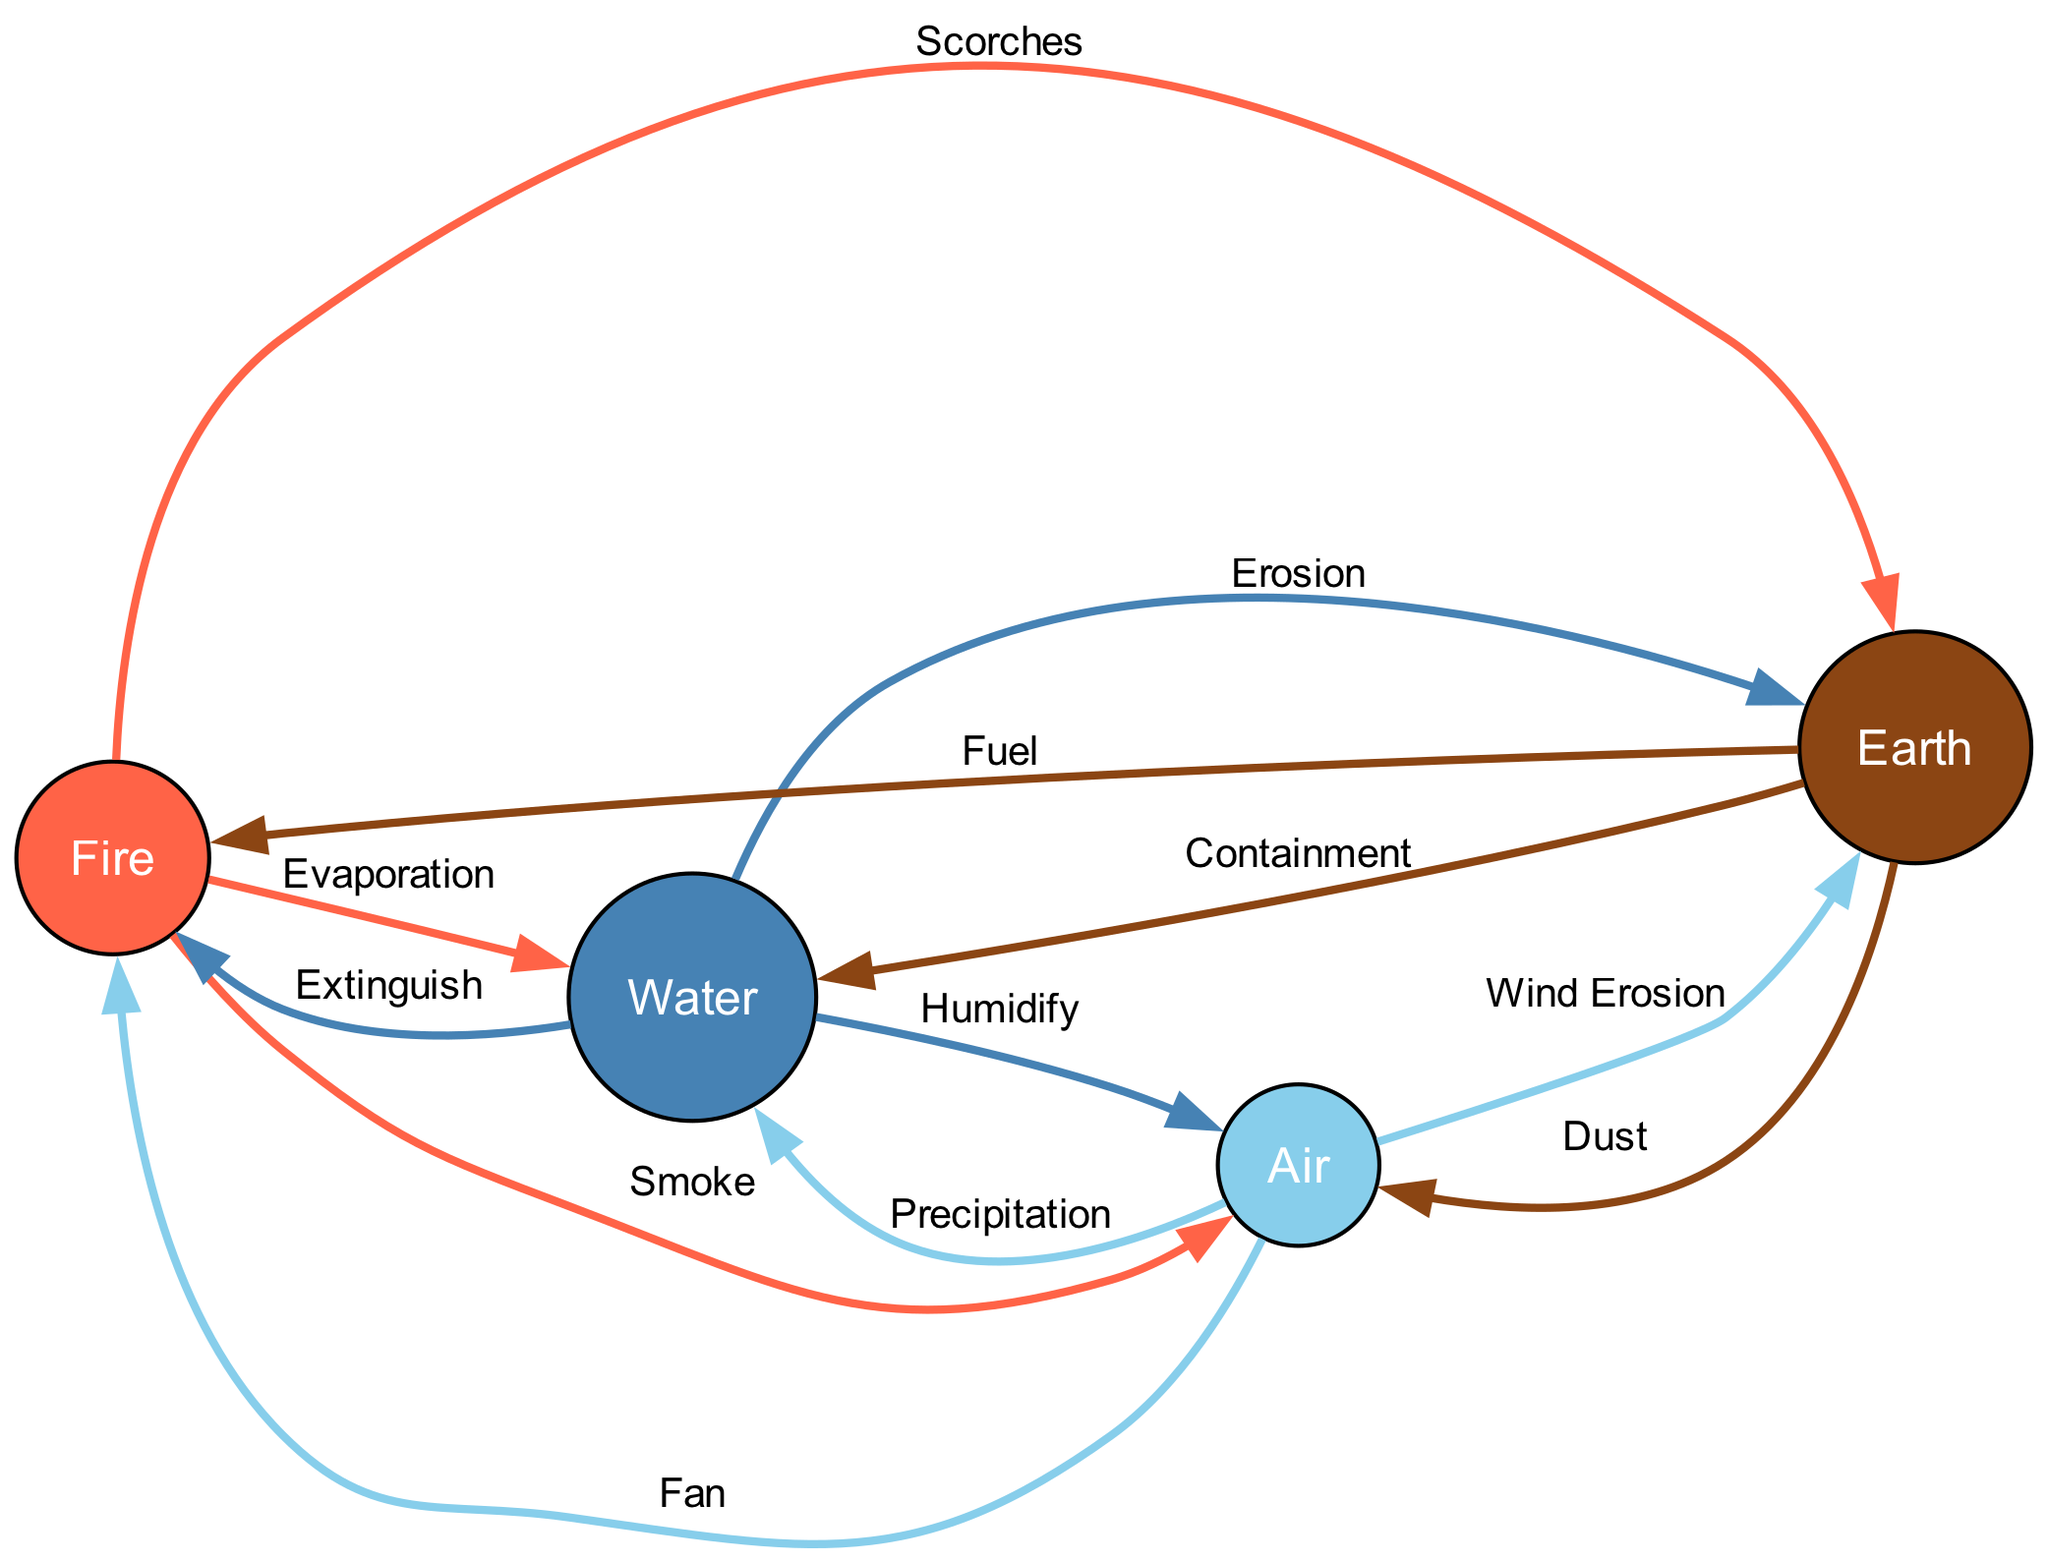what are the nodes in the diagram? The diagram includes four nodes: Fire, Water, Earth, and Air. These are the main elemental forces represented in the diagram.
Answer: Fire, Water, Earth, Air how many edges are there in total? Counting the connections between the nodes, there are a total of 12 edges in the diagram. Each edge represents a relationship between two elemental forces.
Answer: 12 what does Fire produce in Air? According to the diagram, Fire produces Smoke, which is released into Air. This relationship shows the effect of Fire on Air.
Answer: Smoke what is the relationship between Earth and Water? Earth contains and channels Water, forming rivers and lakes. This shows how Earth interacts with Water to maintain water bodies.
Answer: Containment which elemental force does Air erode through wind action? The diagram indicates that Air erodes Earth through wind action, demonstrating how these two forces interact dynamically.
Answer: Earth how does Water affect Fire? The relationship between Water and Fire is defined as Extinguish, meaning Water can extinguish Fire and suppress its flames.
Answer: Extinguish which elemental force is influenced by Fire heating it? Fire heats Water, causing it to evaporate, illustrating how Fire directly interacts with and affects Water.
Answer: Evaporation what interaction occurs between Air and Water related to precipitation? Air carries Water vapor, leading to precipitation, which shows the interaction that results in rain and contributes to the water cycle.
Answer: Precipitation when Fire gets too intense, which element can fan or support it? The diagram shows that Air can fan the flames of Fire, intensifying its heat and supporting its existence.
Answer: Fan what type of relationship does Earth have with Fire in terms of fuel? The diagram indicates that Earth provides fuel for Fire, enabling it to burn. This relationship is fundamental for Fire's existence.
Answer: Fuel 